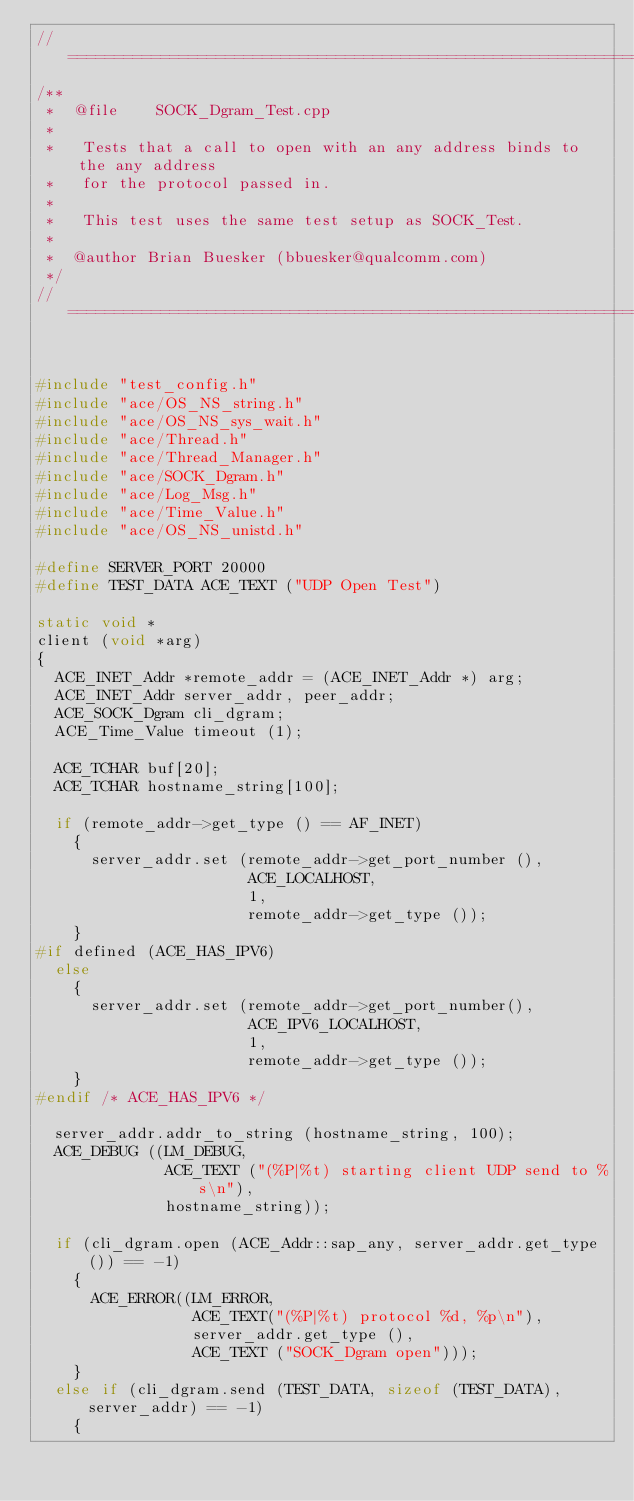Convert code to text. <code><loc_0><loc_0><loc_500><loc_500><_C++_>//=============================================================================
/**
 *  @file    SOCK_Dgram_Test.cpp
 *
 *   Tests that a call to open with an any address binds to the any address
 *   for the protocol passed in.
 *
 *   This test uses the same test setup as SOCK_Test.
 *
 *  @author Brian Buesker (bbuesker@qualcomm.com)
 */
//=============================================================================


#include "test_config.h"
#include "ace/OS_NS_string.h"
#include "ace/OS_NS_sys_wait.h"
#include "ace/Thread.h"
#include "ace/Thread_Manager.h"
#include "ace/SOCK_Dgram.h"
#include "ace/Log_Msg.h"
#include "ace/Time_Value.h"
#include "ace/OS_NS_unistd.h"

#define SERVER_PORT 20000
#define TEST_DATA ACE_TEXT ("UDP Open Test")

static void *
client (void *arg)
{
  ACE_INET_Addr *remote_addr = (ACE_INET_Addr *) arg;
  ACE_INET_Addr server_addr, peer_addr;
  ACE_SOCK_Dgram cli_dgram;
  ACE_Time_Value timeout (1);

  ACE_TCHAR buf[20];
  ACE_TCHAR hostname_string[100];

  if (remote_addr->get_type () == AF_INET)
    {
      server_addr.set (remote_addr->get_port_number (),
                       ACE_LOCALHOST,
                       1,
                       remote_addr->get_type ());
    }
#if defined (ACE_HAS_IPV6)
  else
    {
      server_addr.set (remote_addr->get_port_number(),
                       ACE_IPV6_LOCALHOST,
                       1,
                       remote_addr->get_type ());
    }
#endif /* ACE_HAS_IPV6 */

  server_addr.addr_to_string (hostname_string, 100);
  ACE_DEBUG ((LM_DEBUG,
              ACE_TEXT ("(%P|%t) starting client UDP send to %s\n"),
              hostname_string));

  if (cli_dgram.open (ACE_Addr::sap_any, server_addr.get_type ()) == -1)
    {
      ACE_ERROR((LM_ERROR,
                 ACE_TEXT("(%P|%t) protocol %d, %p\n"),
                 server_addr.get_type (),
                 ACE_TEXT ("SOCK_Dgram open")));
    }
  else if (cli_dgram.send (TEST_DATA, sizeof (TEST_DATA), server_addr) == -1)
    {</code> 